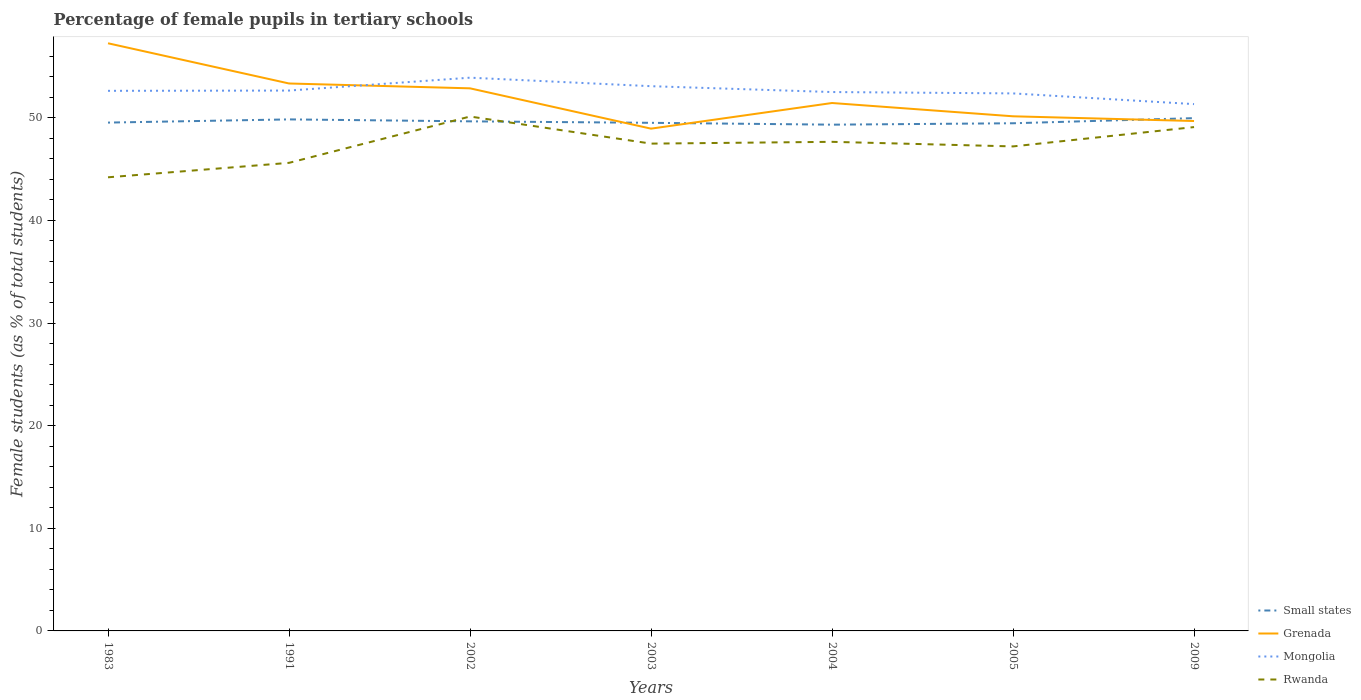How many different coloured lines are there?
Provide a succinct answer. 4. Across all years, what is the maximum percentage of female pupils in tertiary schools in Rwanda?
Offer a terse response. 44.2. What is the total percentage of female pupils in tertiary schools in Rwanda in the graph?
Provide a short and direct response. -3.48. What is the difference between the highest and the second highest percentage of female pupils in tertiary schools in Grenada?
Your answer should be very brief. 8.32. What is the difference between two consecutive major ticks on the Y-axis?
Provide a succinct answer. 10. Does the graph contain grids?
Ensure brevity in your answer.  No. Where does the legend appear in the graph?
Make the answer very short. Bottom right. How many legend labels are there?
Your answer should be very brief. 4. What is the title of the graph?
Offer a very short reply. Percentage of female pupils in tertiary schools. What is the label or title of the Y-axis?
Ensure brevity in your answer.  Female students (as % of total students). What is the Female students (as % of total students) of Small states in 1983?
Provide a succinct answer. 49.53. What is the Female students (as % of total students) of Grenada in 1983?
Your response must be concise. 57.26. What is the Female students (as % of total students) in Mongolia in 1983?
Give a very brief answer. 52.63. What is the Female students (as % of total students) of Rwanda in 1983?
Ensure brevity in your answer.  44.2. What is the Female students (as % of total students) of Small states in 1991?
Your answer should be very brief. 49.84. What is the Female students (as % of total students) in Grenada in 1991?
Ensure brevity in your answer.  53.34. What is the Female students (as % of total students) of Mongolia in 1991?
Offer a very short reply. 52.66. What is the Female students (as % of total students) of Rwanda in 1991?
Offer a very short reply. 45.61. What is the Female students (as % of total students) of Small states in 2002?
Make the answer very short. 49.66. What is the Female students (as % of total students) in Grenada in 2002?
Ensure brevity in your answer.  52.87. What is the Female students (as % of total students) of Mongolia in 2002?
Ensure brevity in your answer.  53.91. What is the Female students (as % of total students) of Rwanda in 2002?
Make the answer very short. 50.13. What is the Female students (as % of total students) of Small states in 2003?
Ensure brevity in your answer.  49.51. What is the Female students (as % of total students) in Grenada in 2003?
Offer a very short reply. 48.94. What is the Female students (as % of total students) of Mongolia in 2003?
Provide a succinct answer. 53.08. What is the Female students (as % of total students) of Rwanda in 2003?
Give a very brief answer. 47.49. What is the Female students (as % of total students) of Small states in 2004?
Keep it short and to the point. 49.33. What is the Female students (as % of total students) of Grenada in 2004?
Your answer should be compact. 51.44. What is the Female students (as % of total students) in Mongolia in 2004?
Your answer should be compact. 52.51. What is the Female students (as % of total students) of Rwanda in 2004?
Make the answer very short. 47.66. What is the Female students (as % of total students) of Small states in 2005?
Your response must be concise. 49.47. What is the Female students (as % of total students) of Grenada in 2005?
Offer a terse response. 50.15. What is the Female students (as % of total students) of Mongolia in 2005?
Give a very brief answer. 52.38. What is the Female students (as % of total students) of Rwanda in 2005?
Provide a short and direct response. 47.21. What is the Female students (as % of total students) in Small states in 2009?
Offer a terse response. 49.97. What is the Female students (as % of total students) of Grenada in 2009?
Ensure brevity in your answer.  49.69. What is the Female students (as % of total students) of Mongolia in 2009?
Provide a short and direct response. 51.34. What is the Female students (as % of total students) in Rwanda in 2009?
Provide a succinct answer. 49.1. Across all years, what is the maximum Female students (as % of total students) of Small states?
Keep it short and to the point. 49.97. Across all years, what is the maximum Female students (as % of total students) in Grenada?
Provide a short and direct response. 57.26. Across all years, what is the maximum Female students (as % of total students) of Mongolia?
Keep it short and to the point. 53.91. Across all years, what is the maximum Female students (as % of total students) of Rwanda?
Offer a very short reply. 50.13. Across all years, what is the minimum Female students (as % of total students) in Small states?
Ensure brevity in your answer.  49.33. Across all years, what is the minimum Female students (as % of total students) in Grenada?
Keep it short and to the point. 48.94. Across all years, what is the minimum Female students (as % of total students) in Mongolia?
Keep it short and to the point. 51.34. Across all years, what is the minimum Female students (as % of total students) of Rwanda?
Provide a short and direct response. 44.2. What is the total Female students (as % of total students) in Small states in the graph?
Offer a very short reply. 347.32. What is the total Female students (as % of total students) of Grenada in the graph?
Provide a short and direct response. 363.7. What is the total Female students (as % of total students) of Mongolia in the graph?
Provide a succinct answer. 368.5. What is the total Female students (as % of total students) in Rwanda in the graph?
Provide a succinct answer. 331.39. What is the difference between the Female students (as % of total students) of Small states in 1983 and that in 1991?
Offer a terse response. -0.31. What is the difference between the Female students (as % of total students) in Grenada in 1983 and that in 1991?
Your answer should be very brief. 3.92. What is the difference between the Female students (as % of total students) in Mongolia in 1983 and that in 1991?
Keep it short and to the point. -0.03. What is the difference between the Female students (as % of total students) of Rwanda in 1983 and that in 1991?
Keep it short and to the point. -1.41. What is the difference between the Female students (as % of total students) of Small states in 1983 and that in 2002?
Offer a very short reply. -0.12. What is the difference between the Female students (as % of total students) in Grenada in 1983 and that in 2002?
Your answer should be very brief. 4.39. What is the difference between the Female students (as % of total students) in Mongolia in 1983 and that in 2002?
Keep it short and to the point. -1.28. What is the difference between the Female students (as % of total students) in Rwanda in 1983 and that in 2002?
Offer a very short reply. -5.92. What is the difference between the Female students (as % of total students) in Small states in 1983 and that in 2003?
Ensure brevity in your answer.  0.02. What is the difference between the Female students (as % of total students) in Grenada in 1983 and that in 2003?
Give a very brief answer. 8.32. What is the difference between the Female students (as % of total students) in Mongolia in 1983 and that in 2003?
Your answer should be very brief. -0.45. What is the difference between the Female students (as % of total students) in Rwanda in 1983 and that in 2003?
Provide a short and direct response. -3.28. What is the difference between the Female students (as % of total students) in Small states in 1983 and that in 2004?
Provide a short and direct response. 0.2. What is the difference between the Female students (as % of total students) in Grenada in 1983 and that in 2004?
Provide a succinct answer. 5.82. What is the difference between the Female students (as % of total students) of Mongolia in 1983 and that in 2004?
Provide a short and direct response. 0.12. What is the difference between the Female students (as % of total students) in Rwanda in 1983 and that in 2004?
Provide a succinct answer. -3.46. What is the difference between the Female students (as % of total students) in Small states in 1983 and that in 2005?
Ensure brevity in your answer.  0.07. What is the difference between the Female students (as % of total students) in Grenada in 1983 and that in 2005?
Provide a short and direct response. 7.12. What is the difference between the Female students (as % of total students) in Mongolia in 1983 and that in 2005?
Your answer should be very brief. 0.25. What is the difference between the Female students (as % of total students) of Rwanda in 1983 and that in 2005?
Your answer should be very brief. -3.01. What is the difference between the Female students (as % of total students) in Small states in 1983 and that in 2009?
Your answer should be very brief. -0.43. What is the difference between the Female students (as % of total students) of Grenada in 1983 and that in 2009?
Give a very brief answer. 7.58. What is the difference between the Female students (as % of total students) in Mongolia in 1983 and that in 2009?
Give a very brief answer. 1.29. What is the difference between the Female students (as % of total students) of Rwanda in 1983 and that in 2009?
Offer a terse response. -4.89. What is the difference between the Female students (as % of total students) in Small states in 1991 and that in 2002?
Keep it short and to the point. 0.19. What is the difference between the Female students (as % of total students) of Grenada in 1991 and that in 2002?
Keep it short and to the point. 0.47. What is the difference between the Female students (as % of total students) in Mongolia in 1991 and that in 2002?
Provide a short and direct response. -1.26. What is the difference between the Female students (as % of total students) in Rwanda in 1991 and that in 2002?
Provide a short and direct response. -4.51. What is the difference between the Female students (as % of total students) of Small states in 1991 and that in 2003?
Provide a short and direct response. 0.33. What is the difference between the Female students (as % of total students) of Grenada in 1991 and that in 2003?
Give a very brief answer. 4.4. What is the difference between the Female students (as % of total students) in Mongolia in 1991 and that in 2003?
Ensure brevity in your answer.  -0.43. What is the difference between the Female students (as % of total students) in Rwanda in 1991 and that in 2003?
Provide a short and direct response. -1.87. What is the difference between the Female students (as % of total students) in Small states in 1991 and that in 2004?
Provide a succinct answer. 0.51. What is the difference between the Female students (as % of total students) of Grenada in 1991 and that in 2004?
Your response must be concise. 1.9. What is the difference between the Female students (as % of total students) in Mongolia in 1991 and that in 2004?
Keep it short and to the point. 0.14. What is the difference between the Female students (as % of total students) of Rwanda in 1991 and that in 2004?
Provide a short and direct response. -2.05. What is the difference between the Female students (as % of total students) of Small states in 1991 and that in 2005?
Offer a terse response. 0.38. What is the difference between the Female students (as % of total students) in Grenada in 1991 and that in 2005?
Give a very brief answer. 3.2. What is the difference between the Female students (as % of total students) of Mongolia in 1991 and that in 2005?
Your response must be concise. 0.28. What is the difference between the Female students (as % of total students) in Rwanda in 1991 and that in 2005?
Ensure brevity in your answer.  -1.6. What is the difference between the Female students (as % of total students) in Small states in 1991 and that in 2009?
Offer a very short reply. -0.12. What is the difference between the Female students (as % of total students) in Grenada in 1991 and that in 2009?
Ensure brevity in your answer.  3.66. What is the difference between the Female students (as % of total students) in Mongolia in 1991 and that in 2009?
Your response must be concise. 1.32. What is the difference between the Female students (as % of total students) of Rwanda in 1991 and that in 2009?
Give a very brief answer. -3.48. What is the difference between the Female students (as % of total students) of Small states in 2002 and that in 2003?
Offer a very short reply. 0.14. What is the difference between the Female students (as % of total students) in Grenada in 2002 and that in 2003?
Your answer should be very brief. 3.93. What is the difference between the Female students (as % of total students) of Mongolia in 2002 and that in 2003?
Your answer should be very brief. 0.83. What is the difference between the Female students (as % of total students) of Rwanda in 2002 and that in 2003?
Ensure brevity in your answer.  2.64. What is the difference between the Female students (as % of total students) in Small states in 2002 and that in 2004?
Make the answer very short. 0.32. What is the difference between the Female students (as % of total students) of Grenada in 2002 and that in 2004?
Make the answer very short. 1.43. What is the difference between the Female students (as % of total students) of Mongolia in 2002 and that in 2004?
Provide a succinct answer. 1.4. What is the difference between the Female students (as % of total students) in Rwanda in 2002 and that in 2004?
Offer a terse response. 2.47. What is the difference between the Female students (as % of total students) of Small states in 2002 and that in 2005?
Offer a very short reply. 0.19. What is the difference between the Female students (as % of total students) of Grenada in 2002 and that in 2005?
Your response must be concise. 2.72. What is the difference between the Female students (as % of total students) in Mongolia in 2002 and that in 2005?
Offer a very short reply. 1.53. What is the difference between the Female students (as % of total students) of Rwanda in 2002 and that in 2005?
Your answer should be very brief. 2.91. What is the difference between the Female students (as % of total students) of Small states in 2002 and that in 2009?
Ensure brevity in your answer.  -0.31. What is the difference between the Female students (as % of total students) in Grenada in 2002 and that in 2009?
Provide a succinct answer. 3.18. What is the difference between the Female students (as % of total students) of Mongolia in 2002 and that in 2009?
Offer a terse response. 2.58. What is the difference between the Female students (as % of total students) in Rwanda in 2002 and that in 2009?
Keep it short and to the point. 1.03. What is the difference between the Female students (as % of total students) of Small states in 2003 and that in 2004?
Keep it short and to the point. 0.18. What is the difference between the Female students (as % of total students) of Grenada in 2003 and that in 2004?
Keep it short and to the point. -2.5. What is the difference between the Female students (as % of total students) of Mongolia in 2003 and that in 2004?
Provide a short and direct response. 0.57. What is the difference between the Female students (as % of total students) in Rwanda in 2003 and that in 2004?
Offer a very short reply. -0.17. What is the difference between the Female students (as % of total students) of Small states in 2003 and that in 2005?
Offer a terse response. 0.04. What is the difference between the Female students (as % of total students) of Grenada in 2003 and that in 2005?
Ensure brevity in your answer.  -1.2. What is the difference between the Female students (as % of total students) of Mongolia in 2003 and that in 2005?
Offer a very short reply. 0.7. What is the difference between the Female students (as % of total students) of Rwanda in 2003 and that in 2005?
Offer a very short reply. 0.27. What is the difference between the Female students (as % of total students) in Small states in 2003 and that in 2009?
Your response must be concise. -0.46. What is the difference between the Female students (as % of total students) in Grenada in 2003 and that in 2009?
Offer a very short reply. -0.74. What is the difference between the Female students (as % of total students) of Mongolia in 2003 and that in 2009?
Your answer should be very brief. 1.75. What is the difference between the Female students (as % of total students) in Rwanda in 2003 and that in 2009?
Your answer should be very brief. -1.61. What is the difference between the Female students (as % of total students) of Small states in 2004 and that in 2005?
Ensure brevity in your answer.  -0.14. What is the difference between the Female students (as % of total students) of Grenada in 2004 and that in 2005?
Make the answer very short. 1.29. What is the difference between the Female students (as % of total students) of Mongolia in 2004 and that in 2005?
Ensure brevity in your answer.  0.13. What is the difference between the Female students (as % of total students) in Rwanda in 2004 and that in 2005?
Provide a succinct answer. 0.45. What is the difference between the Female students (as % of total students) in Small states in 2004 and that in 2009?
Provide a succinct answer. -0.64. What is the difference between the Female students (as % of total students) of Grenada in 2004 and that in 2009?
Offer a very short reply. 1.75. What is the difference between the Female students (as % of total students) of Mongolia in 2004 and that in 2009?
Offer a very short reply. 1.18. What is the difference between the Female students (as % of total students) in Rwanda in 2004 and that in 2009?
Provide a succinct answer. -1.44. What is the difference between the Female students (as % of total students) of Small states in 2005 and that in 2009?
Make the answer very short. -0.5. What is the difference between the Female students (as % of total students) in Grenada in 2005 and that in 2009?
Your answer should be compact. 0.46. What is the difference between the Female students (as % of total students) of Mongolia in 2005 and that in 2009?
Provide a short and direct response. 1.04. What is the difference between the Female students (as % of total students) of Rwanda in 2005 and that in 2009?
Your response must be concise. -1.88. What is the difference between the Female students (as % of total students) in Small states in 1983 and the Female students (as % of total students) in Grenada in 1991?
Your answer should be very brief. -3.81. What is the difference between the Female students (as % of total students) of Small states in 1983 and the Female students (as % of total students) of Mongolia in 1991?
Give a very brief answer. -3.12. What is the difference between the Female students (as % of total students) of Small states in 1983 and the Female students (as % of total students) of Rwanda in 1991?
Offer a terse response. 3.92. What is the difference between the Female students (as % of total students) of Grenada in 1983 and the Female students (as % of total students) of Mongolia in 1991?
Provide a succinct answer. 4.61. What is the difference between the Female students (as % of total students) of Grenada in 1983 and the Female students (as % of total students) of Rwanda in 1991?
Your answer should be very brief. 11.65. What is the difference between the Female students (as % of total students) in Mongolia in 1983 and the Female students (as % of total students) in Rwanda in 1991?
Provide a succinct answer. 7.02. What is the difference between the Female students (as % of total students) in Small states in 1983 and the Female students (as % of total students) in Grenada in 2002?
Provide a succinct answer. -3.34. What is the difference between the Female students (as % of total students) of Small states in 1983 and the Female students (as % of total students) of Mongolia in 2002?
Keep it short and to the point. -4.38. What is the difference between the Female students (as % of total students) in Small states in 1983 and the Female students (as % of total students) in Rwanda in 2002?
Your response must be concise. -0.59. What is the difference between the Female students (as % of total students) in Grenada in 1983 and the Female students (as % of total students) in Mongolia in 2002?
Ensure brevity in your answer.  3.35. What is the difference between the Female students (as % of total students) of Grenada in 1983 and the Female students (as % of total students) of Rwanda in 2002?
Make the answer very short. 7.14. What is the difference between the Female students (as % of total students) in Mongolia in 1983 and the Female students (as % of total students) in Rwanda in 2002?
Offer a very short reply. 2.5. What is the difference between the Female students (as % of total students) of Small states in 1983 and the Female students (as % of total students) of Grenada in 2003?
Your response must be concise. 0.59. What is the difference between the Female students (as % of total students) of Small states in 1983 and the Female students (as % of total students) of Mongolia in 2003?
Provide a short and direct response. -3.55. What is the difference between the Female students (as % of total students) in Small states in 1983 and the Female students (as % of total students) in Rwanda in 2003?
Your response must be concise. 2.05. What is the difference between the Female students (as % of total students) in Grenada in 1983 and the Female students (as % of total students) in Mongolia in 2003?
Your answer should be very brief. 4.18. What is the difference between the Female students (as % of total students) of Grenada in 1983 and the Female students (as % of total students) of Rwanda in 2003?
Offer a terse response. 9.78. What is the difference between the Female students (as % of total students) in Mongolia in 1983 and the Female students (as % of total students) in Rwanda in 2003?
Your answer should be very brief. 5.14. What is the difference between the Female students (as % of total students) in Small states in 1983 and the Female students (as % of total students) in Grenada in 2004?
Give a very brief answer. -1.91. What is the difference between the Female students (as % of total students) of Small states in 1983 and the Female students (as % of total students) of Mongolia in 2004?
Your answer should be compact. -2.98. What is the difference between the Female students (as % of total students) of Small states in 1983 and the Female students (as % of total students) of Rwanda in 2004?
Your answer should be compact. 1.87. What is the difference between the Female students (as % of total students) in Grenada in 1983 and the Female students (as % of total students) in Mongolia in 2004?
Ensure brevity in your answer.  4.75. What is the difference between the Female students (as % of total students) in Grenada in 1983 and the Female students (as % of total students) in Rwanda in 2004?
Make the answer very short. 9.6. What is the difference between the Female students (as % of total students) of Mongolia in 1983 and the Female students (as % of total students) of Rwanda in 2004?
Your answer should be compact. 4.97. What is the difference between the Female students (as % of total students) in Small states in 1983 and the Female students (as % of total students) in Grenada in 2005?
Your response must be concise. -0.61. What is the difference between the Female students (as % of total students) in Small states in 1983 and the Female students (as % of total students) in Mongolia in 2005?
Offer a very short reply. -2.84. What is the difference between the Female students (as % of total students) of Small states in 1983 and the Female students (as % of total students) of Rwanda in 2005?
Your answer should be compact. 2.32. What is the difference between the Female students (as % of total students) in Grenada in 1983 and the Female students (as % of total students) in Mongolia in 2005?
Your answer should be compact. 4.88. What is the difference between the Female students (as % of total students) in Grenada in 1983 and the Female students (as % of total students) in Rwanda in 2005?
Your response must be concise. 10.05. What is the difference between the Female students (as % of total students) in Mongolia in 1983 and the Female students (as % of total students) in Rwanda in 2005?
Your answer should be compact. 5.42. What is the difference between the Female students (as % of total students) in Small states in 1983 and the Female students (as % of total students) in Grenada in 2009?
Keep it short and to the point. -0.15. What is the difference between the Female students (as % of total students) in Small states in 1983 and the Female students (as % of total students) in Mongolia in 2009?
Provide a succinct answer. -1.8. What is the difference between the Female students (as % of total students) in Small states in 1983 and the Female students (as % of total students) in Rwanda in 2009?
Provide a short and direct response. 0.44. What is the difference between the Female students (as % of total students) of Grenada in 1983 and the Female students (as % of total students) of Mongolia in 2009?
Provide a succinct answer. 5.93. What is the difference between the Female students (as % of total students) in Grenada in 1983 and the Female students (as % of total students) in Rwanda in 2009?
Make the answer very short. 8.17. What is the difference between the Female students (as % of total students) in Mongolia in 1983 and the Female students (as % of total students) in Rwanda in 2009?
Your answer should be very brief. 3.53. What is the difference between the Female students (as % of total students) of Small states in 1991 and the Female students (as % of total students) of Grenada in 2002?
Your answer should be very brief. -3.03. What is the difference between the Female students (as % of total students) of Small states in 1991 and the Female students (as % of total students) of Mongolia in 2002?
Offer a very short reply. -4.07. What is the difference between the Female students (as % of total students) in Small states in 1991 and the Female students (as % of total students) in Rwanda in 2002?
Offer a very short reply. -0.28. What is the difference between the Female students (as % of total students) of Grenada in 1991 and the Female students (as % of total students) of Mongolia in 2002?
Keep it short and to the point. -0.57. What is the difference between the Female students (as % of total students) of Grenada in 1991 and the Female students (as % of total students) of Rwanda in 2002?
Make the answer very short. 3.22. What is the difference between the Female students (as % of total students) in Mongolia in 1991 and the Female students (as % of total students) in Rwanda in 2002?
Give a very brief answer. 2.53. What is the difference between the Female students (as % of total students) in Small states in 1991 and the Female students (as % of total students) in Grenada in 2003?
Offer a very short reply. 0.9. What is the difference between the Female students (as % of total students) of Small states in 1991 and the Female students (as % of total students) of Mongolia in 2003?
Keep it short and to the point. -3.24. What is the difference between the Female students (as % of total students) of Small states in 1991 and the Female students (as % of total students) of Rwanda in 2003?
Ensure brevity in your answer.  2.36. What is the difference between the Female students (as % of total students) in Grenada in 1991 and the Female students (as % of total students) in Mongolia in 2003?
Ensure brevity in your answer.  0.26. What is the difference between the Female students (as % of total students) in Grenada in 1991 and the Female students (as % of total students) in Rwanda in 2003?
Offer a very short reply. 5.86. What is the difference between the Female students (as % of total students) of Mongolia in 1991 and the Female students (as % of total students) of Rwanda in 2003?
Ensure brevity in your answer.  5.17. What is the difference between the Female students (as % of total students) of Small states in 1991 and the Female students (as % of total students) of Grenada in 2004?
Keep it short and to the point. -1.6. What is the difference between the Female students (as % of total students) in Small states in 1991 and the Female students (as % of total students) in Mongolia in 2004?
Your answer should be compact. -2.67. What is the difference between the Female students (as % of total students) in Small states in 1991 and the Female students (as % of total students) in Rwanda in 2004?
Provide a short and direct response. 2.19. What is the difference between the Female students (as % of total students) in Grenada in 1991 and the Female students (as % of total students) in Mongolia in 2004?
Your answer should be very brief. 0.83. What is the difference between the Female students (as % of total students) in Grenada in 1991 and the Female students (as % of total students) in Rwanda in 2004?
Give a very brief answer. 5.69. What is the difference between the Female students (as % of total students) in Mongolia in 1991 and the Female students (as % of total students) in Rwanda in 2004?
Provide a succinct answer. 5. What is the difference between the Female students (as % of total students) of Small states in 1991 and the Female students (as % of total students) of Grenada in 2005?
Your answer should be compact. -0.3. What is the difference between the Female students (as % of total students) of Small states in 1991 and the Female students (as % of total students) of Mongolia in 2005?
Give a very brief answer. -2.53. What is the difference between the Female students (as % of total students) of Small states in 1991 and the Female students (as % of total students) of Rwanda in 2005?
Keep it short and to the point. 2.63. What is the difference between the Female students (as % of total students) of Grenada in 1991 and the Female students (as % of total students) of Mongolia in 2005?
Offer a very short reply. 0.97. What is the difference between the Female students (as % of total students) of Grenada in 1991 and the Female students (as % of total students) of Rwanda in 2005?
Make the answer very short. 6.13. What is the difference between the Female students (as % of total students) in Mongolia in 1991 and the Female students (as % of total students) in Rwanda in 2005?
Offer a terse response. 5.44. What is the difference between the Female students (as % of total students) in Small states in 1991 and the Female students (as % of total students) in Grenada in 2009?
Ensure brevity in your answer.  0.16. What is the difference between the Female students (as % of total students) in Small states in 1991 and the Female students (as % of total students) in Mongolia in 2009?
Give a very brief answer. -1.49. What is the difference between the Female students (as % of total students) of Small states in 1991 and the Female students (as % of total students) of Rwanda in 2009?
Provide a short and direct response. 0.75. What is the difference between the Female students (as % of total students) of Grenada in 1991 and the Female students (as % of total students) of Mongolia in 2009?
Your answer should be compact. 2.01. What is the difference between the Female students (as % of total students) of Grenada in 1991 and the Female students (as % of total students) of Rwanda in 2009?
Offer a very short reply. 4.25. What is the difference between the Female students (as % of total students) in Mongolia in 1991 and the Female students (as % of total students) in Rwanda in 2009?
Offer a very short reply. 3.56. What is the difference between the Female students (as % of total students) of Small states in 2002 and the Female students (as % of total students) of Grenada in 2003?
Your answer should be very brief. 0.71. What is the difference between the Female students (as % of total students) of Small states in 2002 and the Female students (as % of total students) of Mongolia in 2003?
Your answer should be very brief. -3.43. What is the difference between the Female students (as % of total students) in Small states in 2002 and the Female students (as % of total students) in Rwanda in 2003?
Make the answer very short. 2.17. What is the difference between the Female students (as % of total students) in Grenada in 2002 and the Female students (as % of total students) in Mongolia in 2003?
Provide a succinct answer. -0.21. What is the difference between the Female students (as % of total students) of Grenada in 2002 and the Female students (as % of total students) of Rwanda in 2003?
Make the answer very short. 5.39. What is the difference between the Female students (as % of total students) in Mongolia in 2002 and the Female students (as % of total students) in Rwanda in 2003?
Keep it short and to the point. 6.43. What is the difference between the Female students (as % of total students) in Small states in 2002 and the Female students (as % of total students) in Grenada in 2004?
Provide a short and direct response. -1.79. What is the difference between the Female students (as % of total students) in Small states in 2002 and the Female students (as % of total students) in Mongolia in 2004?
Give a very brief answer. -2.86. What is the difference between the Female students (as % of total students) in Small states in 2002 and the Female students (as % of total students) in Rwanda in 2004?
Your response must be concise. 2. What is the difference between the Female students (as % of total students) in Grenada in 2002 and the Female students (as % of total students) in Mongolia in 2004?
Ensure brevity in your answer.  0.36. What is the difference between the Female students (as % of total students) of Grenada in 2002 and the Female students (as % of total students) of Rwanda in 2004?
Keep it short and to the point. 5.21. What is the difference between the Female students (as % of total students) of Mongolia in 2002 and the Female students (as % of total students) of Rwanda in 2004?
Keep it short and to the point. 6.25. What is the difference between the Female students (as % of total students) of Small states in 2002 and the Female students (as % of total students) of Grenada in 2005?
Make the answer very short. -0.49. What is the difference between the Female students (as % of total students) in Small states in 2002 and the Female students (as % of total students) in Mongolia in 2005?
Give a very brief answer. -2.72. What is the difference between the Female students (as % of total students) in Small states in 2002 and the Female students (as % of total students) in Rwanda in 2005?
Give a very brief answer. 2.44. What is the difference between the Female students (as % of total students) of Grenada in 2002 and the Female students (as % of total students) of Mongolia in 2005?
Make the answer very short. 0.49. What is the difference between the Female students (as % of total students) in Grenada in 2002 and the Female students (as % of total students) in Rwanda in 2005?
Keep it short and to the point. 5.66. What is the difference between the Female students (as % of total students) of Mongolia in 2002 and the Female students (as % of total students) of Rwanda in 2005?
Offer a very short reply. 6.7. What is the difference between the Female students (as % of total students) in Small states in 2002 and the Female students (as % of total students) in Grenada in 2009?
Give a very brief answer. -0.03. What is the difference between the Female students (as % of total students) of Small states in 2002 and the Female students (as % of total students) of Mongolia in 2009?
Provide a succinct answer. -1.68. What is the difference between the Female students (as % of total students) in Small states in 2002 and the Female students (as % of total students) in Rwanda in 2009?
Your answer should be very brief. 0.56. What is the difference between the Female students (as % of total students) in Grenada in 2002 and the Female students (as % of total students) in Mongolia in 2009?
Your answer should be compact. 1.54. What is the difference between the Female students (as % of total students) of Grenada in 2002 and the Female students (as % of total students) of Rwanda in 2009?
Your response must be concise. 3.78. What is the difference between the Female students (as % of total students) of Mongolia in 2002 and the Female students (as % of total students) of Rwanda in 2009?
Provide a short and direct response. 4.81. What is the difference between the Female students (as % of total students) in Small states in 2003 and the Female students (as % of total students) in Grenada in 2004?
Your answer should be compact. -1.93. What is the difference between the Female students (as % of total students) in Small states in 2003 and the Female students (as % of total students) in Mongolia in 2004?
Keep it short and to the point. -3. What is the difference between the Female students (as % of total students) of Small states in 2003 and the Female students (as % of total students) of Rwanda in 2004?
Provide a succinct answer. 1.85. What is the difference between the Female students (as % of total students) of Grenada in 2003 and the Female students (as % of total students) of Mongolia in 2004?
Your answer should be compact. -3.57. What is the difference between the Female students (as % of total students) of Grenada in 2003 and the Female students (as % of total students) of Rwanda in 2004?
Keep it short and to the point. 1.28. What is the difference between the Female students (as % of total students) in Mongolia in 2003 and the Female students (as % of total students) in Rwanda in 2004?
Offer a terse response. 5.42. What is the difference between the Female students (as % of total students) of Small states in 2003 and the Female students (as % of total students) of Grenada in 2005?
Keep it short and to the point. -0.64. What is the difference between the Female students (as % of total students) in Small states in 2003 and the Female students (as % of total students) in Mongolia in 2005?
Your answer should be very brief. -2.87. What is the difference between the Female students (as % of total students) of Small states in 2003 and the Female students (as % of total students) of Rwanda in 2005?
Your response must be concise. 2.3. What is the difference between the Female students (as % of total students) of Grenada in 2003 and the Female students (as % of total students) of Mongolia in 2005?
Provide a succinct answer. -3.43. What is the difference between the Female students (as % of total students) of Grenada in 2003 and the Female students (as % of total students) of Rwanda in 2005?
Your answer should be very brief. 1.73. What is the difference between the Female students (as % of total students) of Mongolia in 2003 and the Female students (as % of total students) of Rwanda in 2005?
Ensure brevity in your answer.  5.87. What is the difference between the Female students (as % of total students) of Small states in 2003 and the Female students (as % of total students) of Grenada in 2009?
Provide a succinct answer. -0.18. What is the difference between the Female students (as % of total students) of Small states in 2003 and the Female students (as % of total students) of Mongolia in 2009?
Provide a short and direct response. -1.82. What is the difference between the Female students (as % of total students) in Small states in 2003 and the Female students (as % of total students) in Rwanda in 2009?
Provide a short and direct response. 0.42. What is the difference between the Female students (as % of total students) of Grenada in 2003 and the Female students (as % of total students) of Mongolia in 2009?
Your response must be concise. -2.39. What is the difference between the Female students (as % of total students) in Grenada in 2003 and the Female students (as % of total students) in Rwanda in 2009?
Ensure brevity in your answer.  -0.15. What is the difference between the Female students (as % of total students) in Mongolia in 2003 and the Female students (as % of total students) in Rwanda in 2009?
Offer a very short reply. 3.99. What is the difference between the Female students (as % of total students) of Small states in 2004 and the Female students (as % of total students) of Grenada in 2005?
Your response must be concise. -0.82. What is the difference between the Female students (as % of total students) of Small states in 2004 and the Female students (as % of total students) of Mongolia in 2005?
Give a very brief answer. -3.05. What is the difference between the Female students (as % of total students) in Small states in 2004 and the Female students (as % of total students) in Rwanda in 2005?
Your answer should be very brief. 2.12. What is the difference between the Female students (as % of total students) in Grenada in 2004 and the Female students (as % of total students) in Mongolia in 2005?
Offer a very short reply. -0.94. What is the difference between the Female students (as % of total students) of Grenada in 2004 and the Female students (as % of total students) of Rwanda in 2005?
Provide a short and direct response. 4.23. What is the difference between the Female students (as % of total students) of Mongolia in 2004 and the Female students (as % of total students) of Rwanda in 2005?
Your answer should be compact. 5.3. What is the difference between the Female students (as % of total students) in Small states in 2004 and the Female students (as % of total students) in Grenada in 2009?
Offer a very short reply. -0.36. What is the difference between the Female students (as % of total students) of Small states in 2004 and the Female students (as % of total students) of Mongolia in 2009?
Provide a short and direct response. -2. What is the difference between the Female students (as % of total students) in Small states in 2004 and the Female students (as % of total students) in Rwanda in 2009?
Your answer should be very brief. 0.24. What is the difference between the Female students (as % of total students) in Grenada in 2004 and the Female students (as % of total students) in Mongolia in 2009?
Your response must be concise. 0.11. What is the difference between the Female students (as % of total students) of Grenada in 2004 and the Female students (as % of total students) of Rwanda in 2009?
Your answer should be compact. 2.35. What is the difference between the Female students (as % of total students) of Mongolia in 2004 and the Female students (as % of total students) of Rwanda in 2009?
Offer a very short reply. 3.42. What is the difference between the Female students (as % of total students) in Small states in 2005 and the Female students (as % of total students) in Grenada in 2009?
Your answer should be very brief. -0.22. What is the difference between the Female students (as % of total students) in Small states in 2005 and the Female students (as % of total students) in Mongolia in 2009?
Offer a very short reply. -1.87. What is the difference between the Female students (as % of total students) of Small states in 2005 and the Female students (as % of total students) of Rwanda in 2009?
Give a very brief answer. 0.37. What is the difference between the Female students (as % of total students) of Grenada in 2005 and the Female students (as % of total students) of Mongolia in 2009?
Ensure brevity in your answer.  -1.19. What is the difference between the Female students (as % of total students) in Grenada in 2005 and the Female students (as % of total students) in Rwanda in 2009?
Your response must be concise. 1.05. What is the difference between the Female students (as % of total students) in Mongolia in 2005 and the Female students (as % of total students) in Rwanda in 2009?
Keep it short and to the point. 3.28. What is the average Female students (as % of total students) in Small states per year?
Ensure brevity in your answer.  49.62. What is the average Female students (as % of total students) in Grenada per year?
Your answer should be very brief. 51.96. What is the average Female students (as % of total students) in Mongolia per year?
Your answer should be very brief. 52.64. What is the average Female students (as % of total students) of Rwanda per year?
Give a very brief answer. 47.34. In the year 1983, what is the difference between the Female students (as % of total students) in Small states and Female students (as % of total students) in Grenada?
Provide a succinct answer. -7.73. In the year 1983, what is the difference between the Female students (as % of total students) in Small states and Female students (as % of total students) in Mongolia?
Offer a very short reply. -3.1. In the year 1983, what is the difference between the Female students (as % of total students) of Small states and Female students (as % of total students) of Rwanda?
Give a very brief answer. 5.33. In the year 1983, what is the difference between the Female students (as % of total students) of Grenada and Female students (as % of total students) of Mongolia?
Your response must be concise. 4.63. In the year 1983, what is the difference between the Female students (as % of total students) in Grenada and Female students (as % of total students) in Rwanda?
Offer a very short reply. 13.06. In the year 1983, what is the difference between the Female students (as % of total students) in Mongolia and Female students (as % of total students) in Rwanda?
Your response must be concise. 8.43. In the year 1991, what is the difference between the Female students (as % of total students) in Small states and Female students (as % of total students) in Grenada?
Offer a terse response. -3.5. In the year 1991, what is the difference between the Female students (as % of total students) of Small states and Female students (as % of total students) of Mongolia?
Make the answer very short. -2.81. In the year 1991, what is the difference between the Female students (as % of total students) of Small states and Female students (as % of total students) of Rwanda?
Your response must be concise. 4.23. In the year 1991, what is the difference between the Female students (as % of total students) in Grenada and Female students (as % of total students) in Mongolia?
Your response must be concise. 0.69. In the year 1991, what is the difference between the Female students (as % of total students) in Grenada and Female students (as % of total students) in Rwanda?
Give a very brief answer. 7.73. In the year 1991, what is the difference between the Female students (as % of total students) of Mongolia and Female students (as % of total students) of Rwanda?
Your response must be concise. 7.04. In the year 2002, what is the difference between the Female students (as % of total students) in Small states and Female students (as % of total students) in Grenada?
Your answer should be compact. -3.22. In the year 2002, what is the difference between the Female students (as % of total students) of Small states and Female students (as % of total students) of Mongolia?
Provide a succinct answer. -4.25. In the year 2002, what is the difference between the Female students (as % of total students) of Small states and Female students (as % of total students) of Rwanda?
Offer a terse response. -0.47. In the year 2002, what is the difference between the Female students (as % of total students) of Grenada and Female students (as % of total students) of Mongolia?
Your answer should be compact. -1.04. In the year 2002, what is the difference between the Female students (as % of total students) in Grenada and Female students (as % of total students) in Rwanda?
Offer a terse response. 2.75. In the year 2002, what is the difference between the Female students (as % of total students) of Mongolia and Female students (as % of total students) of Rwanda?
Your response must be concise. 3.79. In the year 2003, what is the difference between the Female students (as % of total students) in Small states and Female students (as % of total students) in Grenada?
Ensure brevity in your answer.  0.57. In the year 2003, what is the difference between the Female students (as % of total students) in Small states and Female students (as % of total students) in Mongolia?
Your response must be concise. -3.57. In the year 2003, what is the difference between the Female students (as % of total students) in Small states and Female students (as % of total students) in Rwanda?
Your answer should be very brief. 2.03. In the year 2003, what is the difference between the Female students (as % of total students) of Grenada and Female students (as % of total students) of Mongolia?
Keep it short and to the point. -4.14. In the year 2003, what is the difference between the Female students (as % of total students) in Grenada and Female students (as % of total students) in Rwanda?
Offer a very short reply. 1.46. In the year 2003, what is the difference between the Female students (as % of total students) in Mongolia and Female students (as % of total students) in Rwanda?
Ensure brevity in your answer.  5.6. In the year 2004, what is the difference between the Female students (as % of total students) of Small states and Female students (as % of total students) of Grenada?
Make the answer very short. -2.11. In the year 2004, what is the difference between the Female students (as % of total students) of Small states and Female students (as % of total students) of Mongolia?
Provide a short and direct response. -3.18. In the year 2004, what is the difference between the Female students (as % of total students) of Small states and Female students (as % of total students) of Rwanda?
Offer a very short reply. 1.67. In the year 2004, what is the difference between the Female students (as % of total students) of Grenada and Female students (as % of total students) of Mongolia?
Your answer should be very brief. -1.07. In the year 2004, what is the difference between the Female students (as % of total students) in Grenada and Female students (as % of total students) in Rwanda?
Your response must be concise. 3.78. In the year 2004, what is the difference between the Female students (as % of total students) of Mongolia and Female students (as % of total students) of Rwanda?
Keep it short and to the point. 4.85. In the year 2005, what is the difference between the Female students (as % of total students) of Small states and Female students (as % of total students) of Grenada?
Offer a terse response. -0.68. In the year 2005, what is the difference between the Female students (as % of total students) in Small states and Female students (as % of total students) in Mongolia?
Ensure brevity in your answer.  -2.91. In the year 2005, what is the difference between the Female students (as % of total students) in Small states and Female students (as % of total students) in Rwanda?
Your answer should be very brief. 2.26. In the year 2005, what is the difference between the Female students (as % of total students) in Grenada and Female students (as % of total students) in Mongolia?
Ensure brevity in your answer.  -2.23. In the year 2005, what is the difference between the Female students (as % of total students) of Grenada and Female students (as % of total students) of Rwanda?
Make the answer very short. 2.94. In the year 2005, what is the difference between the Female students (as % of total students) in Mongolia and Female students (as % of total students) in Rwanda?
Provide a succinct answer. 5.17. In the year 2009, what is the difference between the Female students (as % of total students) of Small states and Female students (as % of total students) of Grenada?
Ensure brevity in your answer.  0.28. In the year 2009, what is the difference between the Female students (as % of total students) of Small states and Female students (as % of total students) of Mongolia?
Offer a very short reply. -1.37. In the year 2009, what is the difference between the Female students (as % of total students) of Small states and Female students (as % of total students) of Rwanda?
Your response must be concise. 0.87. In the year 2009, what is the difference between the Female students (as % of total students) in Grenada and Female students (as % of total students) in Mongolia?
Offer a terse response. -1.65. In the year 2009, what is the difference between the Female students (as % of total students) in Grenada and Female students (as % of total students) in Rwanda?
Keep it short and to the point. 0.59. In the year 2009, what is the difference between the Female students (as % of total students) of Mongolia and Female students (as % of total students) of Rwanda?
Provide a short and direct response. 2.24. What is the ratio of the Female students (as % of total students) of Grenada in 1983 to that in 1991?
Provide a short and direct response. 1.07. What is the ratio of the Female students (as % of total students) in Rwanda in 1983 to that in 1991?
Keep it short and to the point. 0.97. What is the ratio of the Female students (as % of total students) of Small states in 1983 to that in 2002?
Give a very brief answer. 1. What is the ratio of the Female students (as % of total students) in Grenada in 1983 to that in 2002?
Give a very brief answer. 1.08. What is the ratio of the Female students (as % of total students) of Mongolia in 1983 to that in 2002?
Ensure brevity in your answer.  0.98. What is the ratio of the Female students (as % of total students) of Rwanda in 1983 to that in 2002?
Make the answer very short. 0.88. What is the ratio of the Female students (as % of total students) in Small states in 1983 to that in 2003?
Keep it short and to the point. 1. What is the ratio of the Female students (as % of total students) of Grenada in 1983 to that in 2003?
Offer a terse response. 1.17. What is the ratio of the Female students (as % of total students) of Mongolia in 1983 to that in 2003?
Give a very brief answer. 0.99. What is the ratio of the Female students (as % of total students) of Rwanda in 1983 to that in 2003?
Offer a terse response. 0.93. What is the ratio of the Female students (as % of total students) in Grenada in 1983 to that in 2004?
Provide a succinct answer. 1.11. What is the ratio of the Female students (as % of total students) in Mongolia in 1983 to that in 2004?
Offer a terse response. 1. What is the ratio of the Female students (as % of total students) in Rwanda in 1983 to that in 2004?
Offer a terse response. 0.93. What is the ratio of the Female students (as % of total students) of Grenada in 1983 to that in 2005?
Make the answer very short. 1.14. What is the ratio of the Female students (as % of total students) of Rwanda in 1983 to that in 2005?
Provide a succinct answer. 0.94. What is the ratio of the Female students (as % of total students) of Small states in 1983 to that in 2009?
Your response must be concise. 0.99. What is the ratio of the Female students (as % of total students) of Grenada in 1983 to that in 2009?
Offer a very short reply. 1.15. What is the ratio of the Female students (as % of total students) in Mongolia in 1983 to that in 2009?
Provide a succinct answer. 1.03. What is the ratio of the Female students (as % of total students) of Rwanda in 1983 to that in 2009?
Provide a short and direct response. 0.9. What is the ratio of the Female students (as % of total students) of Small states in 1991 to that in 2002?
Your response must be concise. 1. What is the ratio of the Female students (as % of total students) in Grenada in 1991 to that in 2002?
Offer a terse response. 1.01. What is the ratio of the Female students (as % of total students) in Mongolia in 1991 to that in 2002?
Give a very brief answer. 0.98. What is the ratio of the Female students (as % of total students) of Rwanda in 1991 to that in 2002?
Offer a terse response. 0.91. What is the ratio of the Female students (as % of total students) of Grenada in 1991 to that in 2003?
Offer a terse response. 1.09. What is the ratio of the Female students (as % of total students) of Mongolia in 1991 to that in 2003?
Offer a terse response. 0.99. What is the ratio of the Female students (as % of total students) in Rwanda in 1991 to that in 2003?
Offer a very short reply. 0.96. What is the ratio of the Female students (as % of total students) in Small states in 1991 to that in 2004?
Offer a terse response. 1.01. What is the ratio of the Female students (as % of total students) in Grenada in 1991 to that in 2004?
Give a very brief answer. 1.04. What is the ratio of the Female students (as % of total students) of Mongolia in 1991 to that in 2004?
Keep it short and to the point. 1. What is the ratio of the Female students (as % of total students) in Rwanda in 1991 to that in 2004?
Give a very brief answer. 0.96. What is the ratio of the Female students (as % of total students) of Small states in 1991 to that in 2005?
Keep it short and to the point. 1.01. What is the ratio of the Female students (as % of total students) in Grenada in 1991 to that in 2005?
Your answer should be compact. 1.06. What is the ratio of the Female students (as % of total students) in Rwanda in 1991 to that in 2005?
Make the answer very short. 0.97. What is the ratio of the Female students (as % of total students) in Grenada in 1991 to that in 2009?
Keep it short and to the point. 1.07. What is the ratio of the Female students (as % of total students) of Mongolia in 1991 to that in 2009?
Provide a succinct answer. 1.03. What is the ratio of the Female students (as % of total students) in Rwanda in 1991 to that in 2009?
Your response must be concise. 0.93. What is the ratio of the Female students (as % of total students) in Grenada in 2002 to that in 2003?
Your answer should be very brief. 1.08. What is the ratio of the Female students (as % of total students) of Mongolia in 2002 to that in 2003?
Give a very brief answer. 1.02. What is the ratio of the Female students (as % of total students) in Rwanda in 2002 to that in 2003?
Your response must be concise. 1.06. What is the ratio of the Female students (as % of total students) of Small states in 2002 to that in 2004?
Provide a succinct answer. 1.01. What is the ratio of the Female students (as % of total students) in Grenada in 2002 to that in 2004?
Provide a short and direct response. 1.03. What is the ratio of the Female students (as % of total students) of Mongolia in 2002 to that in 2004?
Ensure brevity in your answer.  1.03. What is the ratio of the Female students (as % of total students) of Rwanda in 2002 to that in 2004?
Give a very brief answer. 1.05. What is the ratio of the Female students (as % of total students) of Grenada in 2002 to that in 2005?
Offer a terse response. 1.05. What is the ratio of the Female students (as % of total students) of Mongolia in 2002 to that in 2005?
Your answer should be compact. 1.03. What is the ratio of the Female students (as % of total students) in Rwanda in 2002 to that in 2005?
Your answer should be very brief. 1.06. What is the ratio of the Female students (as % of total students) in Small states in 2002 to that in 2009?
Keep it short and to the point. 0.99. What is the ratio of the Female students (as % of total students) of Grenada in 2002 to that in 2009?
Make the answer very short. 1.06. What is the ratio of the Female students (as % of total students) in Mongolia in 2002 to that in 2009?
Your answer should be very brief. 1.05. What is the ratio of the Female students (as % of total students) of Rwanda in 2002 to that in 2009?
Your answer should be compact. 1.02. What is the ratio of the Female students (as % of total students) in Grenada in 2003 to that in 2004?
Offer a terse response. 0.95. What is the ratio of the Female students (as % of total students) in Mongolia in 2003 to that in 2004?
Your answer should be compact. 1.01. What is the ratio of the Female students (as % of total students) of Rwanda in 2003 to that in 2004?
Offer a very short reply. 1. What is the ratio of the Female students (as % of total students) in Small states in 2003 to that in 2005?
Your answer should be compact. 1. What is the ratio of the Female students (as % of total students) of Grenada in 2003 to that in 2005?
Provide a succinct answer. 0.98. What is the ratio of the Female students (as % of total students) in Mongolia in 2003 to that in 2005?
Provide a succinct answer. 1.01. What is the ratio of the Female students (as % of total students) of Rwanda in 2003 to that in 2005?
Give a very brief answer. 1.01. What is the ratio of the Female students (as % of total students) in Small states in 2003 to that in 2009?
Offer a very short reply. 0.99. What is the ratio of the Female students (as % of total students) in Mongolia in 2003 to that in 2009?
Offer a very short reply. 1.03. What is the ratio of the Female students (as % of total students) of Rwanda in 2003 to that in 2009?
Offer a terse response. 0.97. What is the ratio of the Female students (as % of total students) in Grenada in 2004 to that in 2005?
Your answer should be compact. 1.03. What is the ratio of the Female students (as % of total students) in Rwanda in 2004 to that in 2005?
Provide a succinct answer. 1.01. What is the ratio of the Female students (as % of total students) of Small states in 2004 to that in 2009?
Ensure brevity in your answer.  0.99. What is the ratio of the Female students (as % of total students) of Grenada in 2004 to that in 2009?
Your answer should be compact. 1.04. What is the ratio of the Female students (as % of total students) of Mongolia in 2004 to that in 2009?
Your answer should be very brief. 1.02. What is the ratio of the Female students (as % of total students) in Rwanda in 2004 to that in 2009?
Provide a short and direct response. 0.97. What is the ratio of the Female students (as % of total students) of Grenada in 2005 to that in 2009?
Your answer should be very brief. 1.01. What is the ratio of the Female students (as % of total students) of Mongolia in 2005 to that in 2009?
Offer a terse response. 1.02. What is the ratio of the Female students (as % of total students) of Rwanda in 2005 to that in 2009?
Your answer should be very brief. 0.96. What is the difference between the highest and the second highest Female students (as % of total students) in Small states?
Your response must be concise. 0.12. What is the difference between the highest and the second highest Female students (as % of total students) of Grenada?
Your answer should be compact. 3.92. What is the difference between the highest and the second highest Female students (as % of total students) of Mongolia?
Your answer should be very brief. 0.83. What is the difference between the highest and the second highest Female students (as % of total students) in Rwanda?
Give a very brief answer. 1.03. What is the difference between the highest and the lowest Female students (as % of total students) of Small states?
Give a very brief answer. 0.64. What is the difference between the highest and the lowest Female students (as % of total students) of Grenada?
Your answer should be very brief. 8.32. What is the difference between the highest and the lowest Female students (as % of total students) of Mongolia?
Provide a succinct answer. 2.58. What is the difference between the highest and the lowest Female students (as % of total students) of Rwanda?
Offer a very short reply. 5.92. 